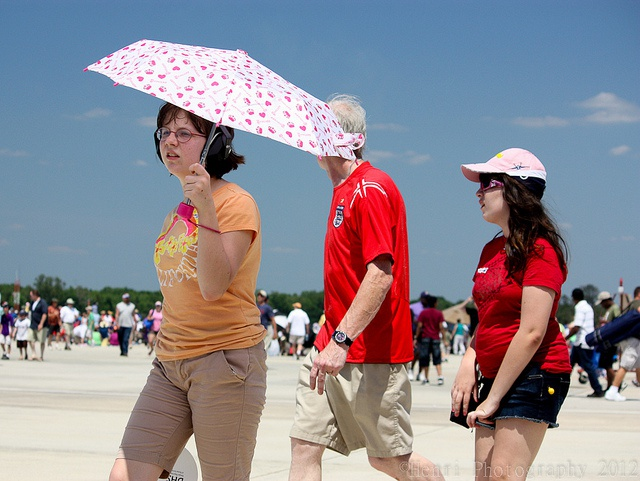Describe the objects in this image and their specific colors. I can see people in gray and tan tones, people in gray, red, tan, and lightgray tones, people in gray, black, tan, maroon, and brown tones, umbrella in gray, lavender, lightpink, and violet tones, and people in gray, black, lavender, and darkgray tones in this image. 